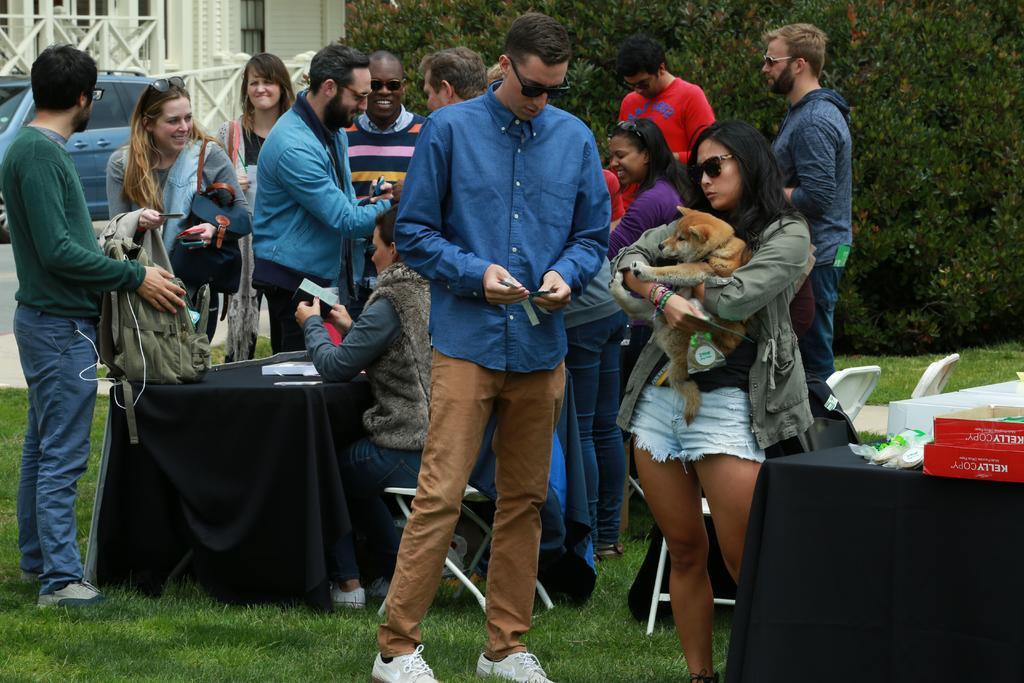In one or two sentences, can you explain what this image depicts? In this image we can see many people. Some are wearing goggles. There is a lady holding an animal. There are tables. On the tables there are packets and some other items. Also there are chairs. On the ground there is grass. And there are bags. In the back there is tree. In the background there is a car and building. 